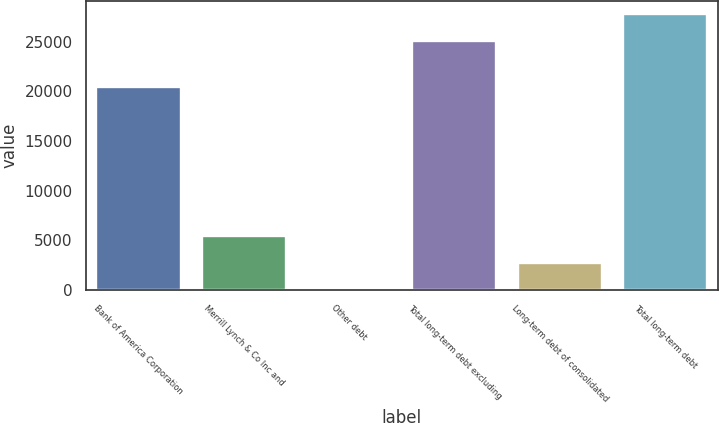Convert chart. <chart><loc_0><loc_0><loc_500><loc_500><bar_chart><fcel>Bank of America Corporation<fcel>Merrill Lynch & Co Inc and<fcel>Other debt<fcel>Total long-term debt excluding<fcel>Long-term debt of consolidated<fcel>Total long-term debt<nl><fcel>20401<fcel>5440.8<fcel>15<fcel>25053<fcel>2727.9<fcel>27765.9<nl></chart> 